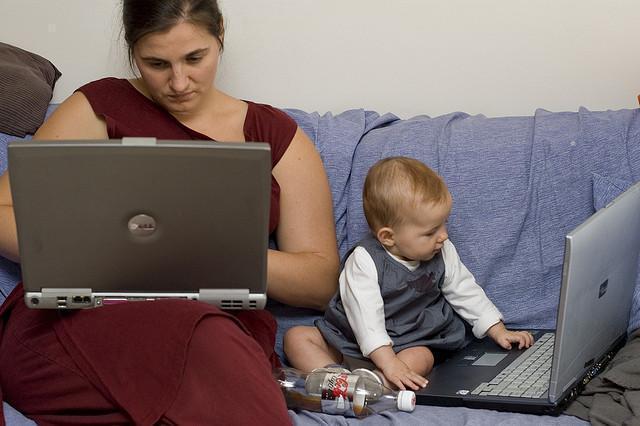Who was drinking from the coke bottle?
Select the accurate answer and provide justification: `Answer: choice
Rationale: srationale.`
Options: Couch, woman, baby, computer. Answer: woman.
Rationale: Children don't drink this beverage 